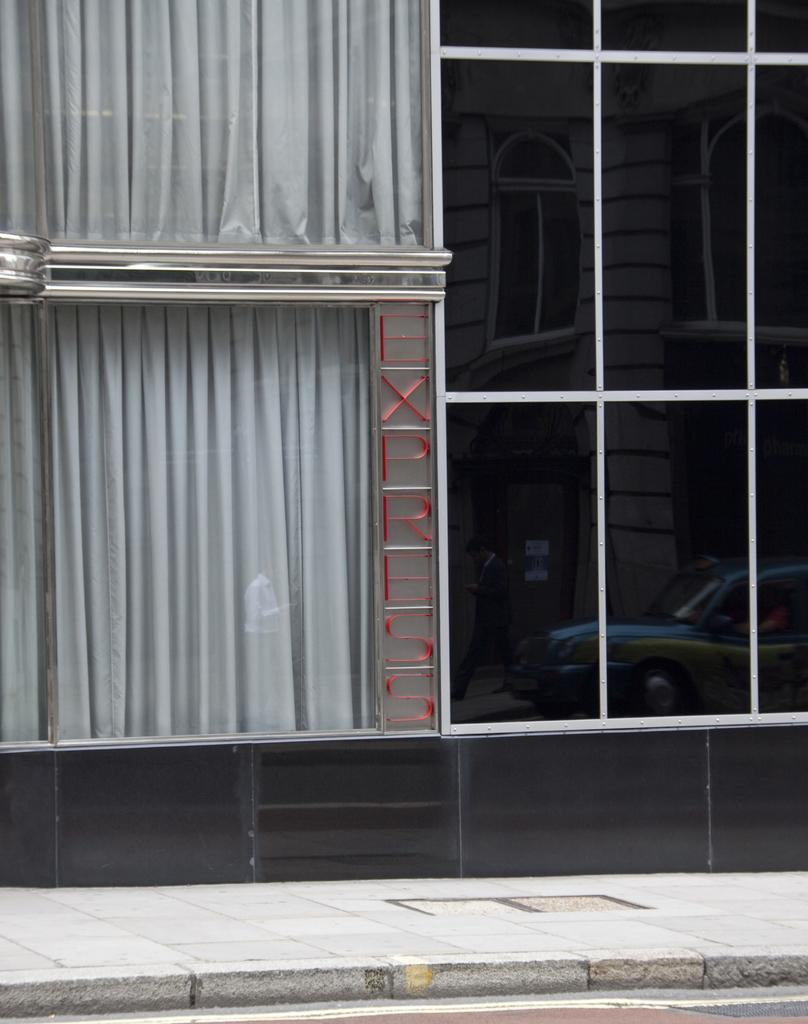What object is present in the image that can hold a liquid? There is a glass in the image. What can be seen in the reflection of the glass? The glass has a reflection of a building and a car. What type of thread is being used to create the sail in the image? There is no sail or thread present in the image; it only features a glass with reflections of a building and a car. 